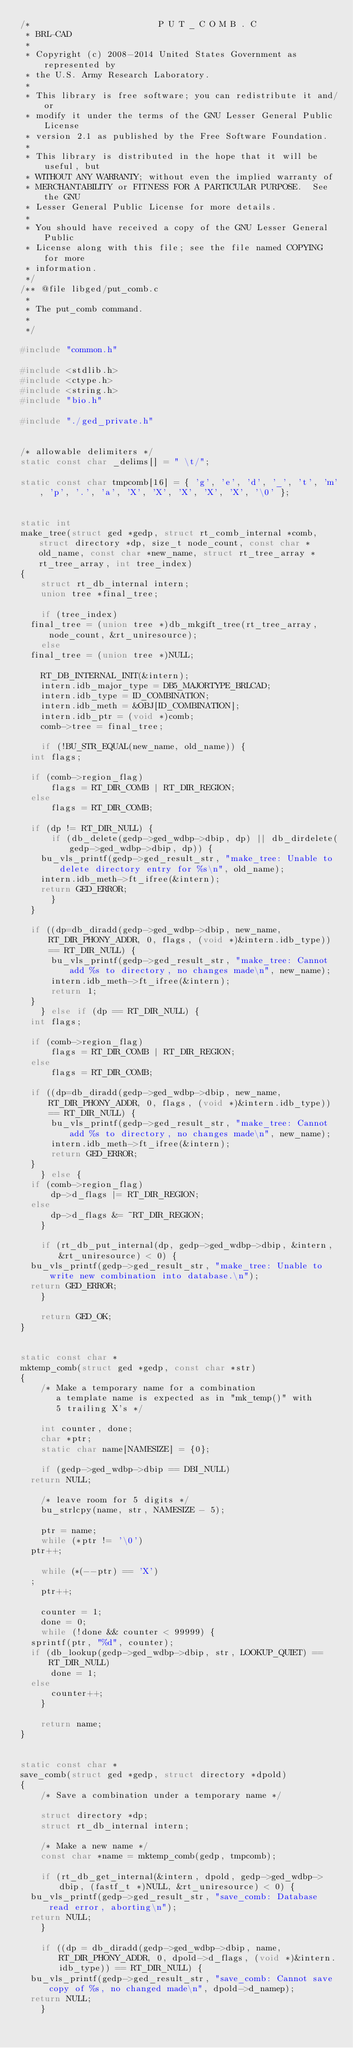<code> <loc_0><loc_0><loc_500><loc_500><_C_>/*                         P U T _ C O M B . C
 * BRL-CAD
 *
 * Copyright (c) 2008-2014 United States Government as represented by
 * the U.S. Army Research Laboratory.
 *
 * This library is free software; you can redistribute it and/or
 * modify it under the terms of the GNU Lesser General Public License
 * version 2.1 as published by the Free Software Foundation.
 *
 * This library is distributed in the hope that it will be useful, but
 * WITHOUT ANY WARRANTY; without even the implied warranty of
 * MERCHANTABILITY or FITNESS FOR A PARTICULAR PURPOSE.  See the GNU
 * Lesser General Public License for more details.
 *
 * You should have received a copy of the GNU Lesser General Public
 * License along with this file; see the file named COPYING for more
 * information.
 */
/** @file libged/put_comb.c
 *
 * The put_comb command.
 *
 */

#include "common.h"

#include <stdlib.h>
#include <ctype.h>
#include <string.h>
#include "bio.h"

#include "./ged_private.h"


/* allowable delimiters */
static const char _delims[] = " \t/";

static const char tmpcomb[16] = { 'g', 'e', 'd', '_', 't', 'm', 'p', '.', 'a', 'X', 'X', 'X', 'X', 'X', '\0' };


static int
make_tree(struct ged *gedp, struct rt_comb_internal *comb, struct directory *dp, size_t node_count, const char *old_name, const char *new_name, struct rt_tree_array *rt_tree_array, int tree_index)
{
    struct rt_db_internal intern;
    union tree *final_tree;

    if (tree_index)
	final_tree = (union tree *)db_mkgift_tree(rt_tree_array, node_count, &rt_uniresource);
    else
	final_tree = (union tree *)NULL;

    RT_DB_INTERNAL_INIT(&intern);
    intern.idb_major_type = DB5_MAJORTYPE_BRLCAD;
    intern.idb_type = ID_COMBINATION;
    intern.idb_meth = &OBJ[ID_COMBINATION];
    intern.idb_ptr = (void *)comb;
    comb->tree = final_tree;

    if (!BU_STR_EQUAL(new_name, old_name)) {
	int flags;

	if (comb->region_flag)
	    flags = RT_DIR_COMB | RT_DIR_REGION;
	else
	    flags = RT_DIR_COMB;

	if (dp != RT_DIR_NULL) {
	    if (db_delete(gedp->ged_wdbp->dbip, dp) || db_dirdelete(gedp->ged_wdbp->dbip, dp)) {
		bu_vls_printf(gedp->ged_result_str, "make_tree: Unable to delete directory entry for %s\n", old_name);
		intern.idb_meth->ft_ifree(&intern);
		return GED_ERROR;
	    }
	}

	if ((dp=db_diradd(gedp->ged_wdbp->dbip, new_name, RT_DIR_PHONY_ADDR, 0, flags, (void *)&intern.idb_type)) == RT_DIR_NULL) {
	    bu_vls_printf(gedp->ged_result_str, "make_tree: Cannot add %s to directory, no changes made\n", new_name);
	    intern.idb_meth->ft_ifree(&intern);
	    return 1;
	}
    } else if (dp == RT_DIR_NULL) {
	int flags;

	if (comb->region_flag)
	    flags = RT_DIR_COMB | RT_DIR_REGION;
	else
	    flags = RT_DIR_COMB;

	if ((dp=db_diradd(gedp->ged_wdbp->dbip, new_name, RT_DIR_PHONY_ADDR, 0, flags, (void *)&intern.idb_type)) == RT_DIR_NULL) {
	    bu_vls_printf(gedp->ged_result_str, "make_tree: Cannot add %s to directory, no changes made\n", new_name);
	    intern.idb_meth->ft_ifree(&intern);
	    return GED_ERROR;
	}
    } else {
	if (comb->region_flag)
	    dp->d_flags |= RT_DIR_REGION;
	else
	    dp->d_flags &= ~RT_DIR_REGION;
    }

    if (rt_db_put_internal(dp, gedp->ged_wdbp->dbip, &intern, &rt_uniresource) < 0) {
	bu_vls_printf(gedp->ged_result_str, "make_tree: Unable to write new combination into database.\n");
	return GED_ERROR;
    }

    return GED_OK;
}


static const char *
mktemp_comb(struct ged *gedp, const char *str)
{
    /* Make a temporary name for a combination
       a template name is expected as in "mk_temp()" with
       5 trailing X's */

    int counter, done;
    char *ptr;
    static char name[NAMESIZE] = {0};

    if (gedp->ged_wdbp->dbip == DBI_NULL)
	return NULL;

    /* leave room for 5 digits */
    bu_strlcpy(name, str, NAMESIZE - 5);

    ptr = name;
    while (*ptr != '\0')
	ptr++;

    while (*(--ptr) == 'X')
	;
    ptr++;

    counter = 1;
    done = 0;
    while (!done && counter < 99999) {
	sprintf(ptr, "%d", counter);
	if (db_lookup(gedp->ged_wdbp->dbip, str, LOOKUP_QUIET) == RT_DIR_NULL)
	    done = 1;
	else
	    counter++;
    }

    return name;
}


static const char *
save_comb(struct ged *gedp, struct directory *dpold)
{
    /* Save a combination under a temporary name */

    struct directory *dp;
    struct rt_db_internal intern;

    /* Make a new name */
    const char *name = mktemp_comb(gedp, tmpcomb);

    if (rt_db_get_internal(&intern, dpold, gedp->ged_wdbp->dbip, (fastf_t *)NULL, &rt_uniresource) < 0) {
	bu_vls_printf(gedp->ged_result_str, "save_comb: Database read error, aborting\n");
	return NULL;
    }

    if ((dp = db_diradd(gedp->ged_wdbp->dbip, name, RT_DIR_PHONY_ADDR, 0, dpold->d_flags, (void *)&intern.idb_type)) == RT_DIR_NULL) {
	bu_vls_printf(gedp->ged_result_str, "save_comb: Cannot save copy of %s, no changed made\n", dpold->d_namep);
	return NULL;
    }
</code> 